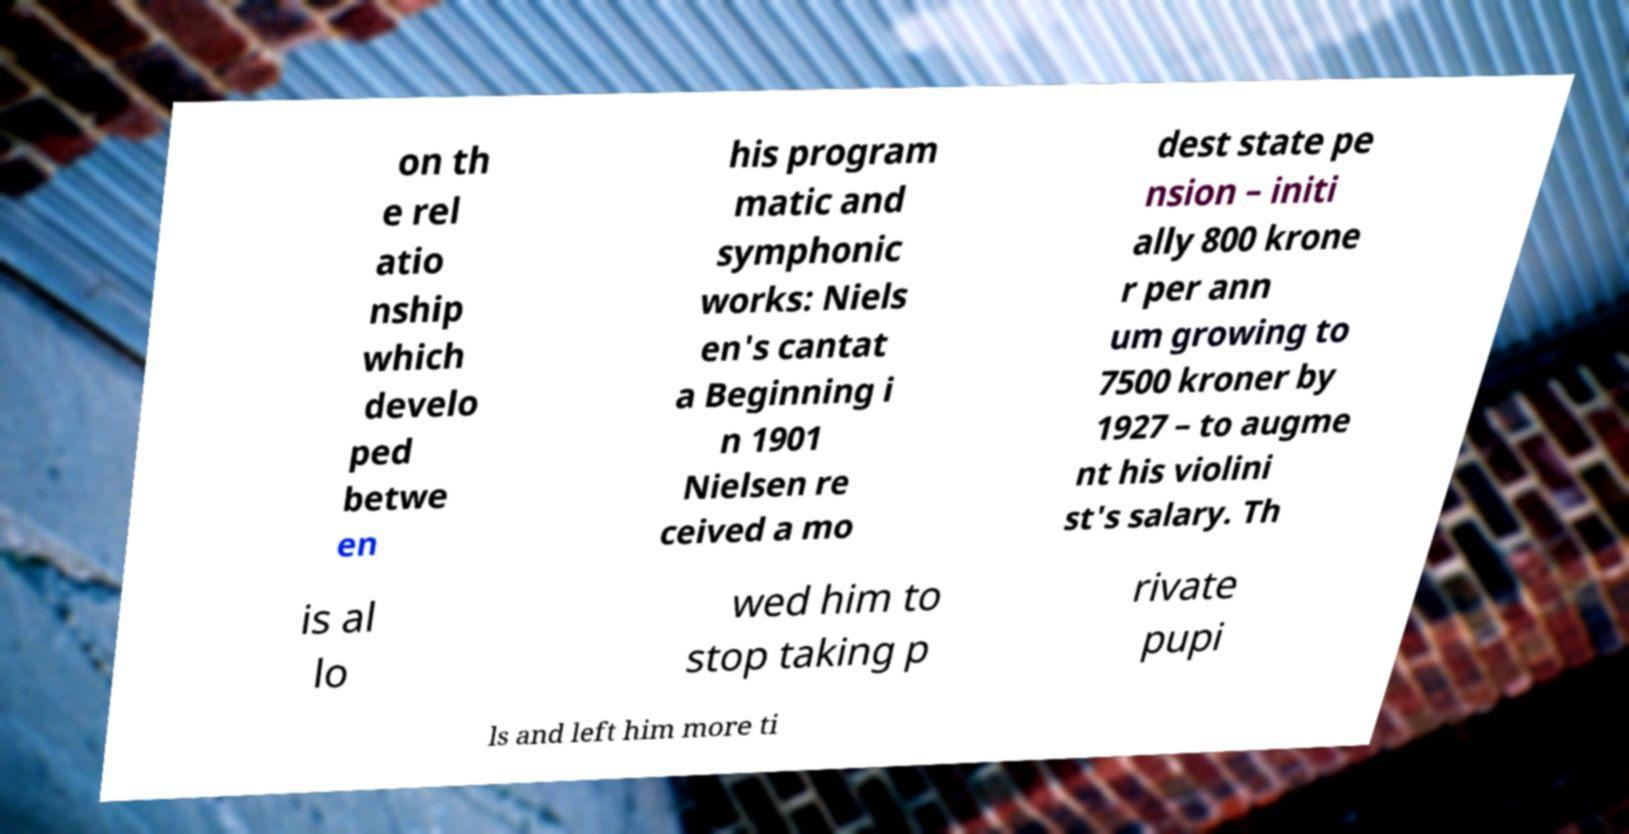For documentation purposes, I need the text within this image transcribed. Could you provide that? on th e rel atio nship which develo ped betwe en his program matic and symphonic works: Niels en's cantat a Beginning i n 1901 Nielsen re ceived a mo dest state pe nsion – initi ally 800 krone r per ann um growing to 7500 kroner by 1927 – to augme nt his violini st's salary. Th is al lo wed him to stop taking p rivate pupi ls and left him more ti 